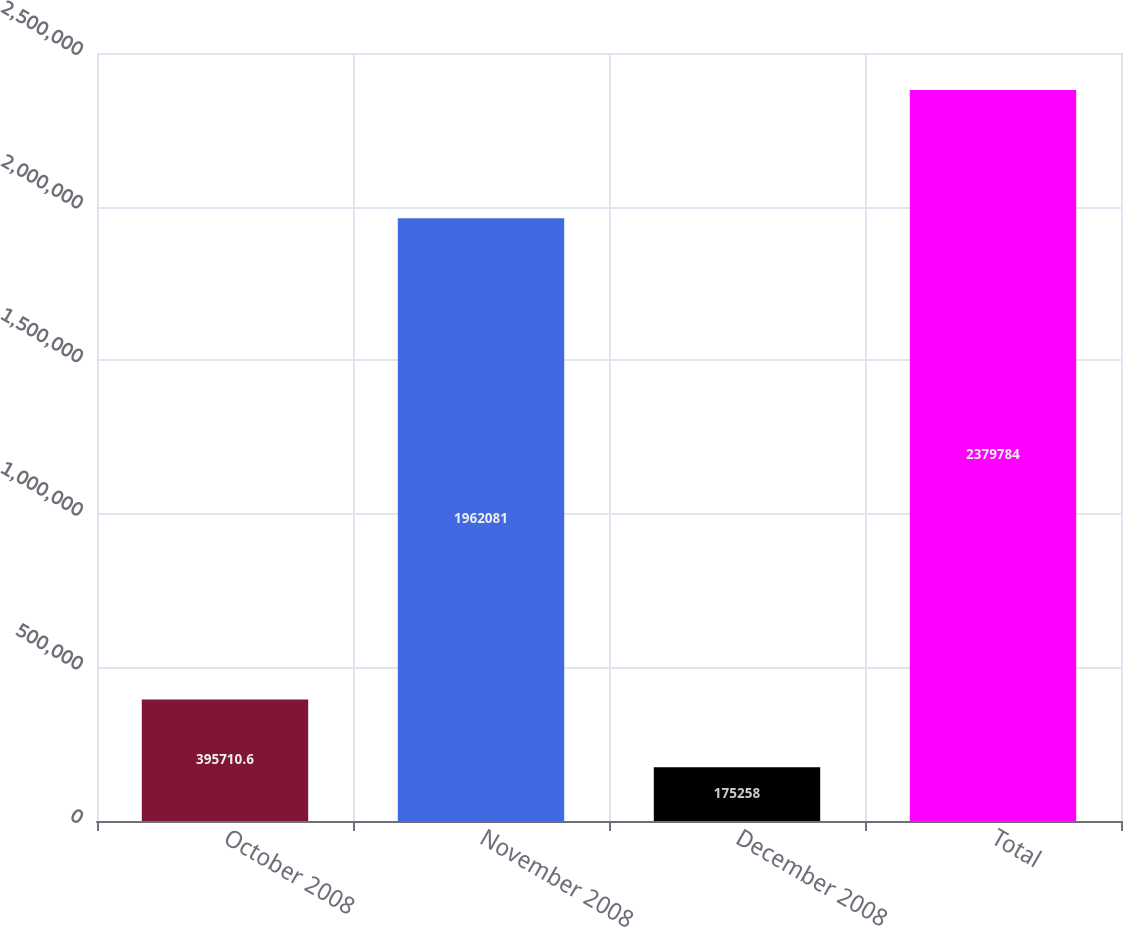Convert chart to OTSL. <chart><loc_0><loc_0><loc_500><loc_500><bar_chart><fcel>October 2008<fcel>November 2008<fcel>December 2008<fcel>Total<nl><fcel>395711<fcel>1.96208e+06<fcel>175258<fcel>2.37978e+06<nl></chart> 